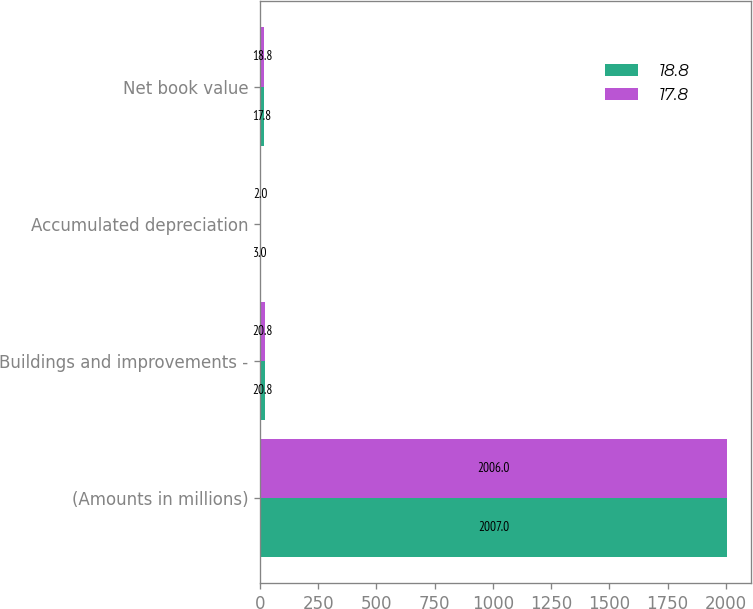Convert chart. <chart><loc_0><loc_0><loc_500><loc_500><stacked_bar_chart><ecel><fcel>(Amounts in millions)<fcel>Buildings and improvements -<fcel>Accumulated depreciation<fcel>Net book value<nl><fcel>18.8<fcel>2007<fcel>20.8<fcel>3<fcel>17.8<nl><fcel>17.8<fcel>2006<fcel>20.8<fcel>2<fcel>18.8<nl></chart> 